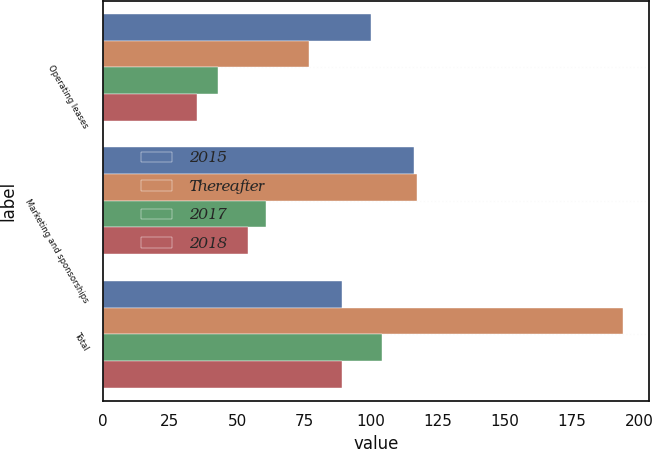Convert chart to OTSL. <chart><loc_0><loc_0><loc_500><loc_500><stacked_bar_chart><ecel><fcel>Operating leases<fcel>Marketing and sponsorships<fcel>Total<nl><fcel>2015<fcel>100<fcel>116<fcel>89<nl><fcel>Thereafter<fcel>77<fcel>117<fcel>194<nl><fcel>2017<fcel>43<fcel>61<fcel>104<nl><fcel>2018<fcel>35<fcel>54<fcel>89<nl></chart> 